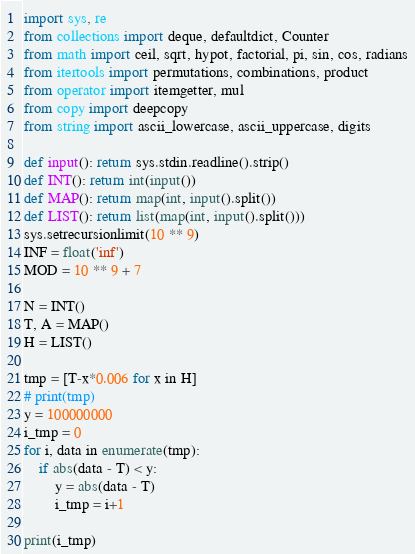<code> <loc_0><loc_0><loc_500><loc_500><_Python_>import sys, re
from collections import deque, defaultdict, Counter
from math import ceil, sqrt, hypot, factorial, pi, sin, cos, radians
from itertools import permutations, combinations, product
from operator import itemgetter, mul
from copy import deepcopy
from string import ascii_lowercase, ascii_uppercase, digits

def input(): return sys.stdin.readline().strip()
def INT(): return int(input())
def MAP(): return map(int, input().split())
def LIST(): return list(map(int, input().split()))
sys.setrecursionlimit(10 ** 9)
INF = float('inf')
MOD = 10 ** 9 + 7

N = INT()
T, A = MAP()
H = LIST()

tmp = [T-x*0.006 for x in H]
# print(tmp)
y = 100000000
i_tmp = 0
for i, data in enumerate(tmp):
	if abs(data - T) < y:
		y = abs(data - T)
		i_tmp = i+1

print(i_tmp)
</code> 